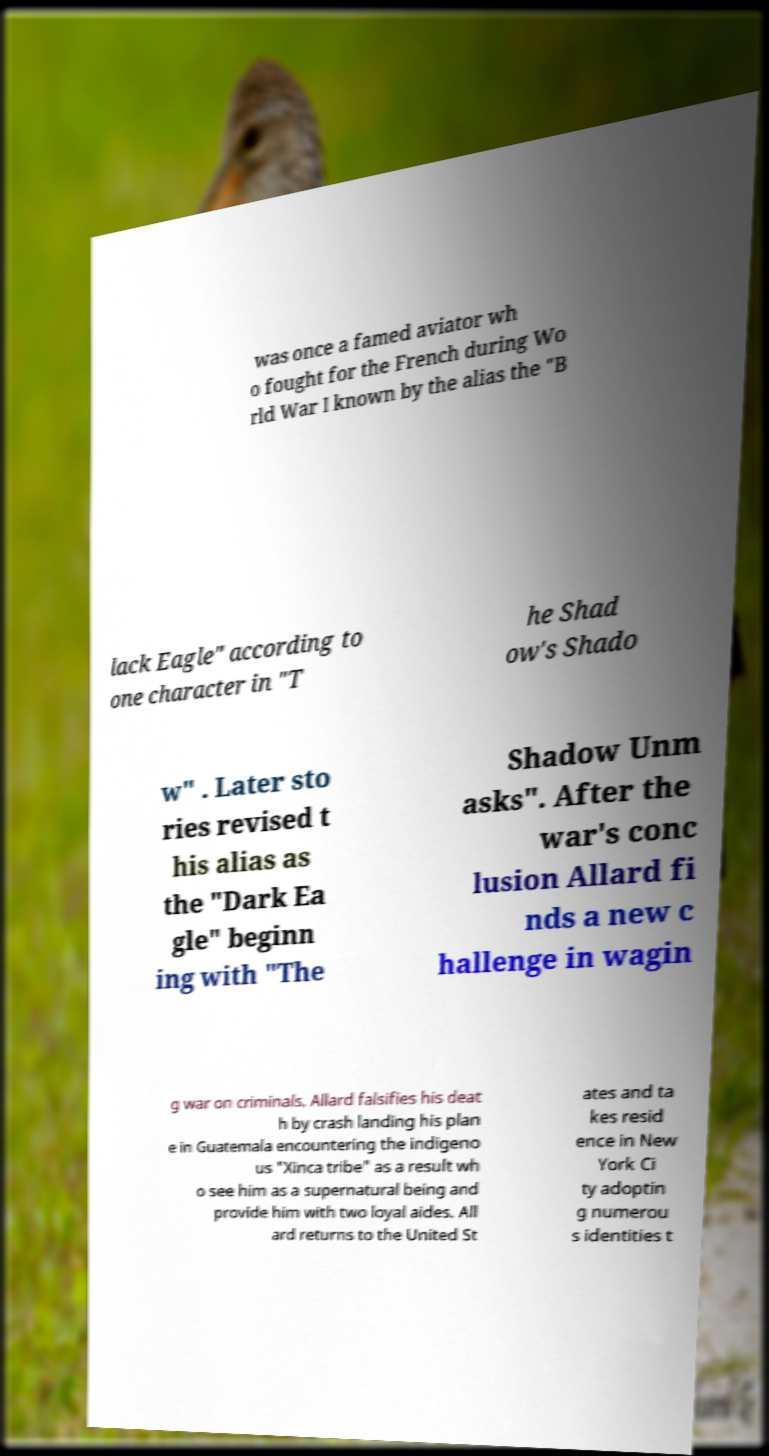Could you assist in decoding the text presented in this image and type it out clearly? was once a famed aviator wh o fought for the French during Wo rld War I known by the alias the "B lack Eagle" according to one character in "T he Shad ow's Shado w" . Later sto ries revised t his alias as the "Dark Ea gle" beginn ing with "The Shadow Unm asks". After the war's conc lusion Allard fi nds a new c hallenge in wagin g war on criminals. Allard falsifies his deat h by crash landing his plan e in Guatemala encountering the indigeno us "Xinca tribe" as a result wh o see him as a supernatural being and provide him with two loyal aides. All ard returns to the United St ates and ta kes resid ence in New York Ci ty adoptin g numerou s identities t 